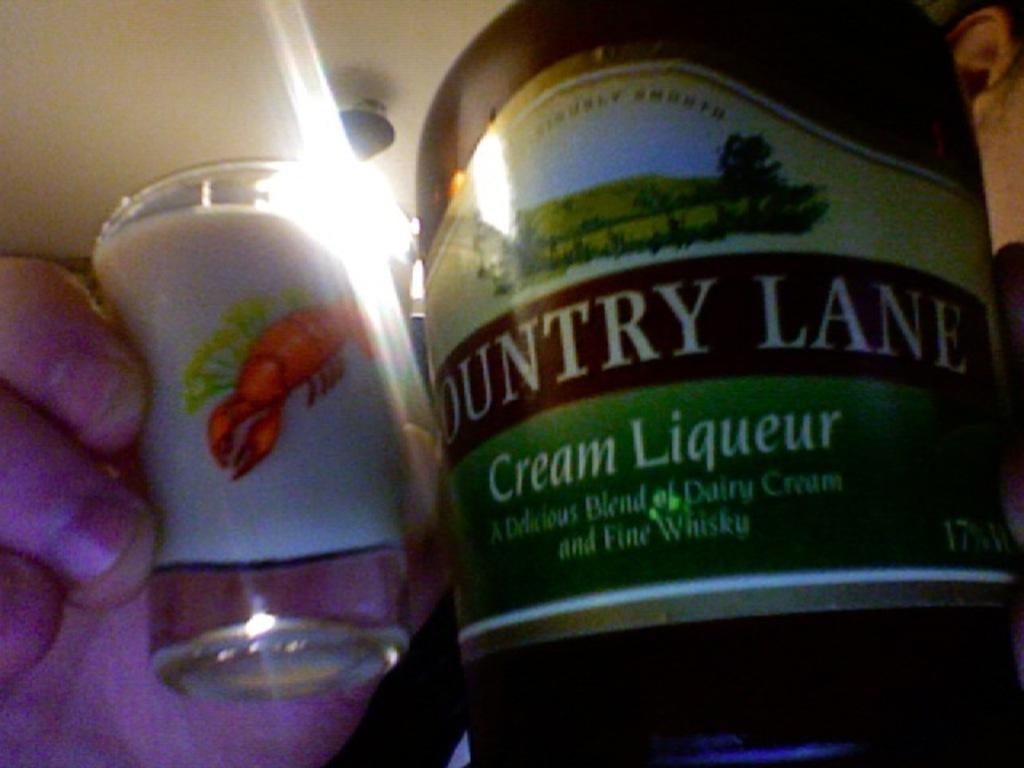What type of liqueur is shown?
Give a very brief answer. Cream. What brand is it?
Your answer should be very brief. Country lane. 